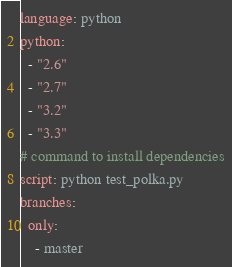Convert code to text. <code><loc_0><loc_0><loc_500><loc_500><_YAML_>language: python
python:
  - "2.6"
  - "2.7"
  - "3.2"
  - "3.3"
# command to install dependencies
script: python test_polka.py
branches:
  only:
    - master
</code> 